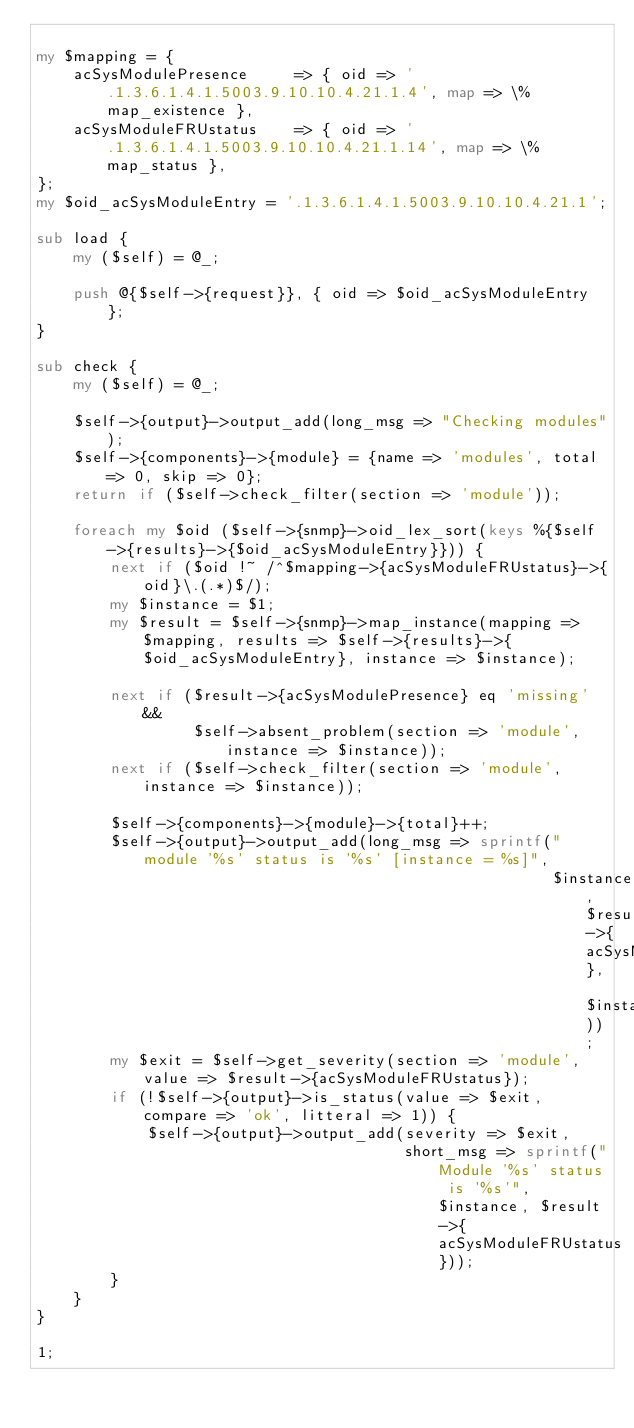Convert code to text. <code><loc_0><loc_0><loc_500><loc_500><_Perl_>
my $mapping = {
    acSysModulePresence     => { oid => '.1.3.6.1.4.1.5003.9.10.10.4.21.1.4', map => \%map_existence },
    acSysModuleFRUstatus    => { oid => '.1.3.6.1.4.1.5003.9.10.10.4.21.1.14', map => \%map_status },
};
my $oid_acSysModuleEntry = '.1.3.6.1.4.1.5003.9.10.10.4.21.1';

sub load {
    my ($self) = @_;
    
    push @{$self->{request}}, { oid => $oid_acSysModuleEntry };
}

sub check {
    my ($self) = @_;

    $self->{output}->output_add(long_msg => "Checking modules");
    $self->{components}->{module} = {name => 'modules', total => 0, skip => 0};
    return if ($self->check_filter(section => 'module'));

    foreach my $oid ($self->{snmp}->oid_lex_sort(keys %{$self->{results}->{$oid_acSysModuleEntry}})) {
        next if ($oid !~ /^$mapping->{acSysModuleFRUstatus}->{oid}\.(.*)$/);
        my $instance = $1;
        my $result = $self->{snmp}->map_instance(mapping => $mapping, results => $self->{results}->{$oid_acSysModuleEntry}, instance => $instance);
        
        next if ($result->{acSysModulePresence} eq 'missing' &&
                 $self->absent_problem(section => 'module', instance => $instance));
        next if ($self->check_filter(section => 'module', instance => $instance));

        $self->{components}->{module}->{total}++;
        $self->{output}->output_add(long_msg => sprintf("module '%s' status is '%s' [instance = %s]",
                                                        $instance, $result->{acSysModuleFRUstatus}, $instance));
        my $exit = $self->get_severity(section => 'module', value => $result->{acSysModuleFRUstatus});
        if (!$self->{output}->is_status(value => $exit, compare => 'ok', litteral => 1)) {
            $self->{output}->output_add(severity => $exit,
                                        short_msg => sprintf("Module '%s' status is '%s'", $instance, $result->{acSysModuleFRUstatus}));
        }
    }
}

1;</code> 